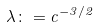<formula> <loc_0><loc_0><loc_500><loc_500>\lambda \colon = c ^ { - 3 / 2 }</formula> 